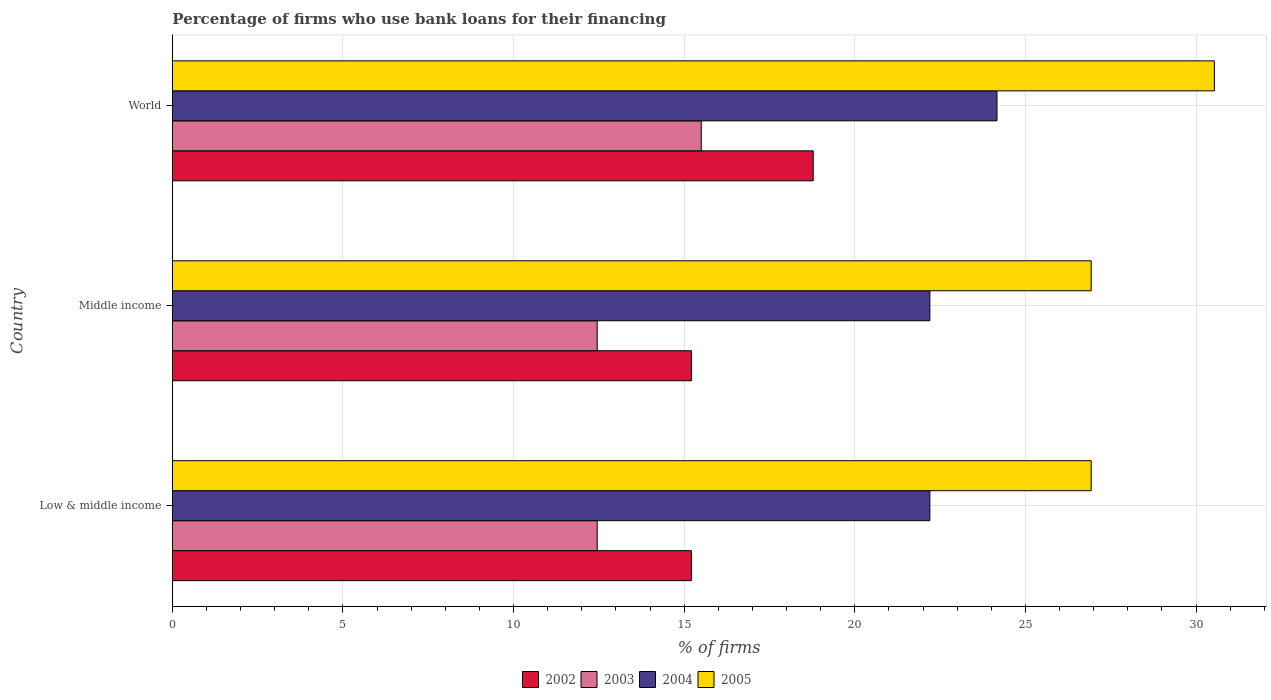How many bars are there on the 1st tick from the bottom?
Your response must be concise. 4. What is the label of the 3rd group of bars from the top?
Offer a terse response. Low & middle income. In how many cases, is the number of bars for a given country not equal to the number of legend labels?
Your answer should be very brief. 0. What is the percentage of firms who use bank loans for their financing in 2005 in Middle income?
Provide a succinct answer. 26.93. Across all countries, what is the maximum percentage of firms who use bank loans for their financing in 2004?
Your answer should be compact. 24.17. Across all countries, what is the minimum percentage of firms who use bank loans for their financing in 2004?
Provide a succinct answer. 22.2. In which country was the percentage of firms who use bank loans for their financing in 2003 maximum?
Your answer should be compact. World. What is the total percentage of firms who use bank loans for their financing in 2003 in the graph?
Provide a short and direct response. 40.4. What is the difference between the percentage of firms who use bank loans for their financing in 2004 in Low & middle income and that in World?
Offer a very short reply. -1.97. What is the difference between the percentage of firms who use bank loans for their financing in 2002 in World and the percentage of firms who use bank loans for their financing in 2004 in Low & middle income?
Keep it short and to the point. -3.42. What is the average percentage of firms who use bank loans for their financing in 2002 per country?
Keep it short and to the point. 16.4. What is the difference between the percentage of firms who use bank loans for their financing in 2005 and percentage of firms who use bank loans for their financing in 2002 in Low & middle income?
Your response must be concise. 11.72. Is the difference between the percentage of firms who use bank loans for their financing in 2005 in Low & middle income and World greater than the difference between the percentage of firms who use bank loans for their financing in 2002 in Low & middle income and World?
Make the answer very short. No. What is the difference between the highest and the second highest percentage of firms who use bank loans for their financing in 2003?
Your answer should be very brief. 3.05. What is the difference between the highest and the lowest percentage of firms who use bank loans for their financing in 2005?
Give a very brief answer. 3.61. In how many countries, is the percentage of firms who use bank loans for their financing in 2004 greater than the average percentage of firms who use bank loans for their financing in 2004 taken over all countries?
Make the answer very short. 1. What does the 4th bar from the top in Middle income represents?
Make the answer very short. 2002. Are all the bars in the graph horizontal?
Your response must be concise. Yes. How many countries are there in the graph?
Keep it short and to the point. 3. What is the difference between two consecutive major ticks on the X-axis?
Ensure brevity in your answer.  5. Are the values on the major ticks of X-axis written in scientific E-notation?
Make the answer very short. No. How many legend labels are there?
Make the answer very short. 4. How are the legend labels stacked?
Make the answer very short. Horizontal. What is the title of the graph?
Provide a succinct answer. Percentage of firms who use bank loans for their financing. What is the label or title of the X-axis?
Your answer should be compact. % of firms. What is the label or title of the Y-axis?
Provide a succinct answer. Country. What is the % of firms of 2002 in Low & middle income?
Offer a terse response. 15.21. What is the % of firms of 2003 in Low & middle income?
Offer a terse response. 12.45. What is the % of firms in 2004 in Low & middle income?
Your response must be concise. 22.2. What is the % of firms in 2005 in Low & middle income?
Make the answer very short. 26.93. What is the % of firms in 2002 in Middle income?
Your answer should be compact. 15.21. What is the % of firms in 2003 in Middle income?
Provide a short and direct response. 12.45. What is the % of firms of 2004 in Middle income?
Offer a terse response. 22.2. What is the % of firms of 2005 in Middle income?
Ensure brevity in your answer.  26.93. What is the % of firms in 2002 in World?
Your response must be concise. 18.78. What is the % of firms of 2003 in World?
Provide a short and direct response. 15.5. What is the % of firms in 2004 in World?
Provide a short and direct response. 24.17. What is the % of firms in 2005 in World?
Ensure brevity in your answer.  30.54. Across all countries, what is the maximum % of firms of 2002?
Give a very brief answer. 18.78. Across all countries, what is the maximum % of firms of 2004?
Provide a succinct answer. 24.17. Across all countries, what is the maximum % of firms in 2005?
Your response must be concise. 30.54. Across all countries, what is the minimum % of firms of 2002?
Provide a short and direct response. 15.21. Across all countries, what is the minimum % of firms in 2003?
Your answer should be very brief. 12.45. Across all countries, what is the minimum % of firms of 2005?
Offer a very short reply. 26.93. What is the total % of firms of 2002 in the graph?
Make the answer very short. 49.21. What is the total % of firms in 2003 in the graph?
Provide a succinct answer. 40.4. What is the total % of firms of 2004 in the graph?
Offer a very short reply. 68.57. What is the total % of firms in 2005 in the graph?
Provide a succinct answer. 84.39. What is the difference between the % of firms in 2003 in Low & middle income and that in Middle income?
Give a very brief answer. 0. What is the difference between the % of firms in 2004 in Low & middle income and that in Middle income?
Provide a short and direct response. 0. What is the difference between the % of firms in 2002 in Low & middle income and that in World?
Offer a very short reply. -3.57. What is the difference between the % of firms in 2003 in Low & middle income and that in World?
Keep it short and to the point. -3.05. What is the difference between the % of firms of 2004 in Low & middle income and that in World?
Offer a terse response. -1.97. What is the difference between the % of firms of 2005 in Low & middle income and that in World?
Offer a very short reply. -3.61. What is the difference between the % of firms of 2002 in Middle income and that in World?
Make the answer very short. -3.57. What is the difference between the % of firms of 2003 in Middle income and that in World?
Your response must be concise. -3.05. What is the difference between the % of firms of 2004 in Middle income and that in World?
Your answer should be very brief. -1.97. What is the difference between the % of firms of 2005 in Middle income and that in World?
Provide a short and direct response. -3.61. What is the difference between the % of firms of 2002 in Low & middle income and the % of firms of 2003 in Middle income?
Keep it short and to the point. 2.76. What is the difference between the % of firms in 2002 in Low & middle income and the % of firms in 2004 in Middle income?
Your answer should be very brief. -6.99. What is the difference between the % of firms of 2002 in Low & middle income and the % of firms of 2005 in Middle income?
Make the answer very short. -11.72. What is the difference between the % of firms in 2003 in Low & middle income and the % of firms in 2004 in Middle income?
Your answer should be compact. -9.75. What is the difference between the % of firms in 2003 in Low & middle income and the % of firms in 2005 in Middle income?
Make the answer very short. -14.48. What is the difference between the % of firms in 2004 in Low & middle income and the % of firms in 2005 in Middle income?
Ensure brevity in your answer.  -4.73. What is the difference between the % of firms in 2002 in Low & middle income and the % of firms in 2003 in World?
Your response must be concise. -0.29. What is the difference between the % of firms in 2002 in Low & middle income and the % of firms in 2004 in World?
Provide a short and direct response. -8.95. What is the difference between the % of firms of 2002 in Low & middle income and the % of firms of 2005 in World?
Offer a terse response. -15.33. What is the difference between the % of firms of 2003 in Low & middle income and the % of firms of 2004 in World?
Offer a very short reply. -11.72. What is the difference between the % of firms of 2003 in Low & middle income and the % of firms of 2005 in World?
Keep it short and to the point. -18.09. What is the difference between the % of firms of 2004 in Low & middle income and the % of firms of 2005 in World?
Keep it short and to the point. -8.34. What is the difference between the % of firms of 2002 in Middle income and the % of firms of 2003 in World?
Offer a very short reply. -0.29. What is the difference between the % of firms in 2002 in Middle income and the % of firms in 2004 in World?
Your answer should be very brief. -8.95. What is the difference between the % of firms in 2002 in Middle income and the % of firms in 2005 in World?
Your answer should be very brief. -15.33. What is the difference between the % of firms in 2003 in Middle income and the % of firms in 2004 in World?
Offer a very short reply. -11.72. What is the difference between the % of firms of 2003 in Middle income and the % of firms of 2005 in World?
Make the answer very short. -18.09. What is the difference between the % of firms in 2004 in Middle income and the % of firms in 2005 in World?
Provide a succinct answer. -8.34. What is the average % of firms of 2002 per country?
Make the answer very short. 16.4. What is the average % of firms of 2003 per country?
Provide a succinct answer. 13.47. What is the average % of firms of 2004 per country?
Your response must be concise. 22.86. What is the average % of firms of 2005 per country?
Your answer should be very brief. 28.13. What is the difference between the % of firms of 2002 and % of firms of 2003 in Low & middle income?
Your response must be concise. 2.76. What is the difference between the % of firms of 2002 and % of firms of 2004 in Low & middle income?
Your response must be concise. -6.99. What is the difference between the % of firms of 2002 and % of firms of 2005 in Low & middle income?
Give a very brief answer. -11.72. What is the difference between the % of firms in 2003 and % of firms in 2004 in Low & middle income?
Ensure brevity in your answer.  -9.75. What is the difference between the % of firms of 2003 and % of firms of 2005 in Low & middle income?
Make the answer very short. -14.48. What is the difference between the % of firms of 2004 and % of firms of 2005 in Low & middle income?
Your response must be concise. -4.73. What is the difference between the % of firms in 2002 and % of firms in 2003 in Middle income?
Give a very brief answer. 2.76. What is the difference between the % of firms of 2002 and % of firms of 2004 in Middle income?
Provide a succinct answer. -6.99. What is the difference between the % of firms of 2002 and % of firms of 2005 in Middle income?
Keep it short and to the point. -11.72. What is the difference between the % of firms in 2003 and % of firms in 2004 in Middle income?
Provide a short and direct response. -9.75. What is the difference between the % of firms of 2003 and % of firms of 2005 in Middle income?
Provide a short and direct response. -14.48. What is the difference between the % of firms in 2004 and % of firms in 2005 in Middle income?
Offer a very short reply. -4.73. What is the difference between the % of firms of 2002 and % of firms of 2003 in World?
Your answer should be very brief. 3.28. What is the difference between the % of firms in 2002 and % of firms in 2004 in World?
Your answer should be very brief. -5.39. What is the difference between the % of firms of 2002 and % of firms of 2005 in World?
Provide a succinct answer. -11.76. What is the difference between the % of firms in 2003 and % of firms in 2004 in World?
Keep it short and to the point. -8.67. What is the difference between the % of firms in 2003 and % of firms in 2005 in World?
Provide a short and direct response. -15.04. What is the difference between the % of firms of 2004 and % of firms of 2005 in World?
Offer a terse response. -6.37. What is the ratio of the % of firms of 2002 in Low & middle income to that in Middle income?
Provide a short and direct response. 1. What is the ratio of the % of firms of 2004 in Low & middle income to that in Middle income?
Give a very brief answer. 1. What is the ratio of the % of firms in 2002 in Low & middle income to that in World?
Provide a succinct answer. 0.81. What is the ratio of the % of firms of 2003 in Low & middle income to that in World?
Provide a short and direct response. 0.8. What is the ratio of the % of firms of 2004 in Low & middle income to that in World?
Ensure brevity in your answer.  0.92. What is the ratio of the % of firms in 2005 in Low & middle income to that in World?
Your answer should be compact. 0.88. What is the ratio of the % of firms of 2002 in Middle income to that in World?
Your answer should be compact. 0.81. What is the ratio of the % of firms of 2003 in Middle income to that in World?
Offer a very short reply. 0.8. What is the ratio of the % of firms of 2004 in Middle income to that in World?
Offer a very short reply. 0.92. What is the ratio of the % of firms in 2005 in Middle income to that in World?
Provide a succinct answer. 0.88. What is the difference between the highest and the second highest % of firms in 2002?
Ensure brevity in your answer.  3.57. What is the difference between the highest and the second highest % of firms in 2003?
Give a very brief answer. 3.05. What is the difference between the highest and the second highest % of firms of 2004?
Offer a very short reply. 1.97. What is the difference between the highest and the second highest % of firms of 2005?
Offer a terse response. 3.61. What is the difference between the highest and the lowest % of firms of 2002?
Your response must be concise. 3.57. What is the difference between the highest and the lowest % of firms in 2003?
Keep it short and to the point. 3.05. What is the difference between the highest and the lowest % of firms of 2004?
Ensure brevity in your answer.  1.97. What is the difference between the highest and the lowest % of firms of 2005?
Provide a succinct answer. 3.61. 